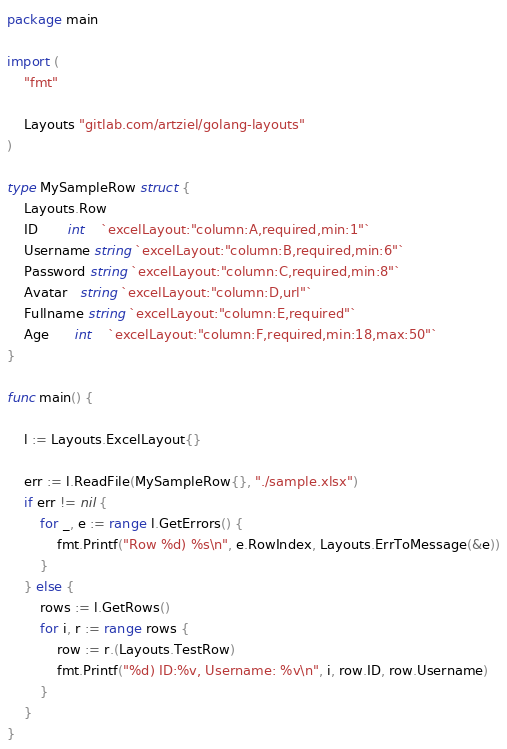<code> <loc_0><loc_0><loc_500><loc_500><_Go_>package main

import (
	"fmt"

	Layouts "gitlab.com/artziel/golang-layouts"
)

type MySampleRow struct {
	Layouts.Row
	ID       int    `excelLayout:"column:A,required,min:1"`
	Username string `excelLayout:"column:B,required,min:6"`
	Password string `excelLayout:"column:C,required,min:8"`
	Avatar   string `excelLayout:"column:D,url"`
	Fullname string `excelLayout:"column:E,required"`
	Age      int    `excelLayout:"column:F,required,min:18,max:50"`
}

func main() {

	l := Layouts.ExcelLayout{}

	err := l.ReadFile(MySampleRow{}, "./sample.xlsx")
	if err != nil {
		for _, e := range l.GetErrors() {
			fmt.Printf("Row %d) %s\n", e.RowIndex, Layouts.ErrToMessage(&e))
		}
	} else {
		rows := l.GetRows()
		for i, r := range rows {
			row := r.(Layouts.TestRow)
			fmt.Printf("%d) ID:%v, Username: %v\n", i, row.ID, row.Username)
		}
	}
}
</code> 